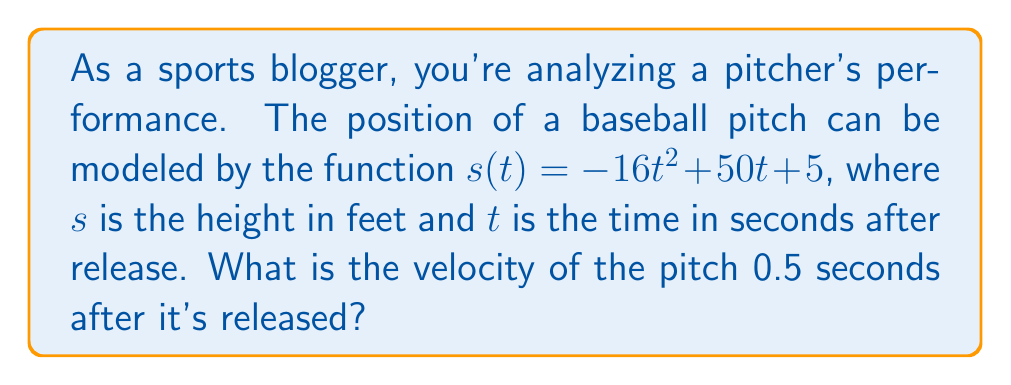Could you help me with this problem? To solve this problem, we need to follow these steps:

1) The velocity of an object is the derivative of its position function. So, we need to find $v(t) = s'(t)$.

2) Given $s(t) = -16t^2 + 50t + 5$, let's differentiate:
   
   $v(t) = s'(t) = -32t + 50$

3) Now that we have the velocity function, we need to find the velocity at $t = 0.5$ seconds.

4) Substitute $t = 0.5$ into our velocity function:

   $v(0.5) = -32(0.5) + 50$
   
   $= -16 + 50$
   
   $= 34$

5) The units for velocity will be feet per second (ft/s), as the original function had height in feet and time in seconds.
Answer: 34 ft/s 